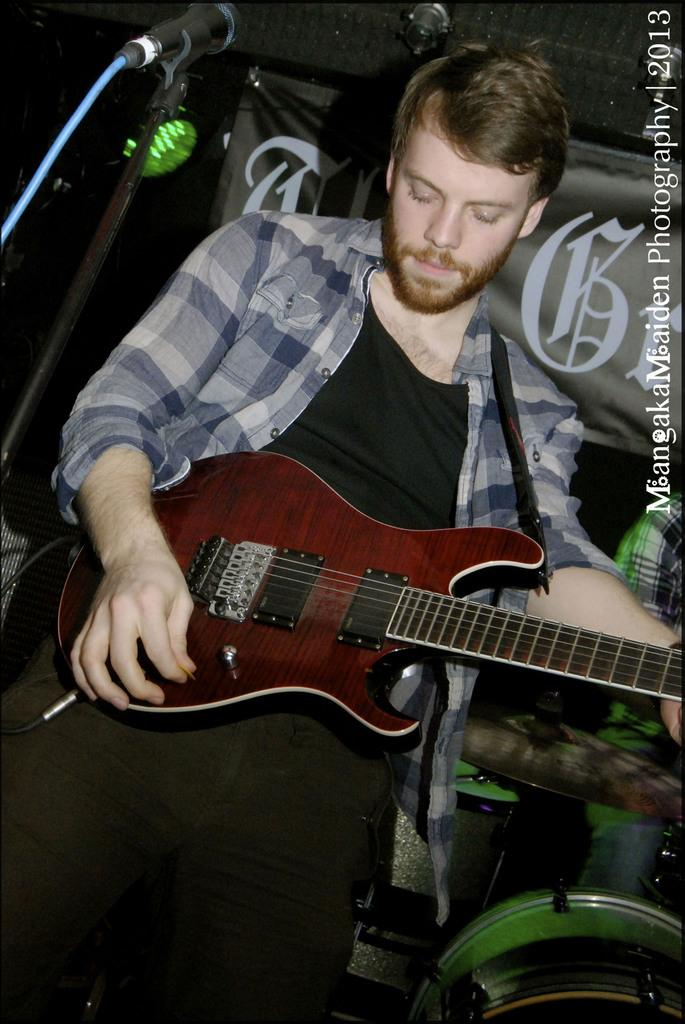What musical instruments can be seen in the background of the image? There is a flexi, drums, and a cymbal in the background of the image. What is the man in the image doing? The man is standing in front of a microphone and playing a guitar. What might be the purpose of the microphone in the image? The microphone might be used for amplifying the man's voice or guitar playing. Can you describe the spark caused by the earthquake in the image? There is no earthquake or spark present in the image. What type of flight is the man taking in the image? There is no flight or airplane in the image; it features a man playing a guitar in front of a microphone. 